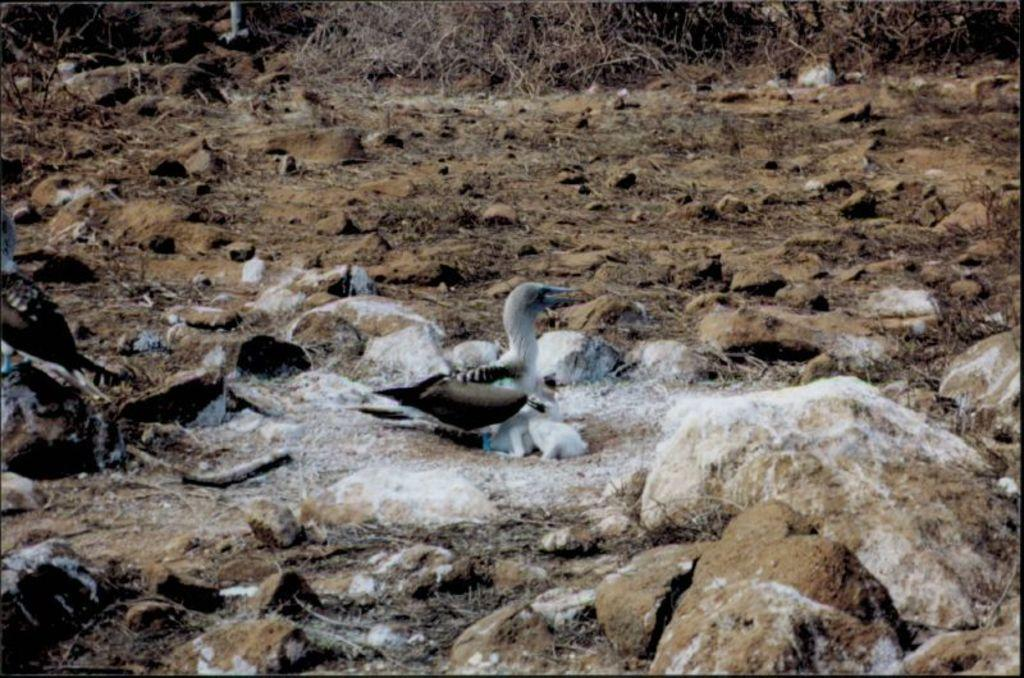What type of animals are on the ground in the image? There are birds on the ground in the image. What else can be seen on the ground besides the birds? There are stones and dried branches of a tree on the ground. Where is the son being treated in the image? There is no son or hospital present in the image; it features birds, stones, and dried branches of a tree on the ground. What type of cart is being used to transport the branches in the image? There is no cart present in the image; the branches are lying on the ground. 